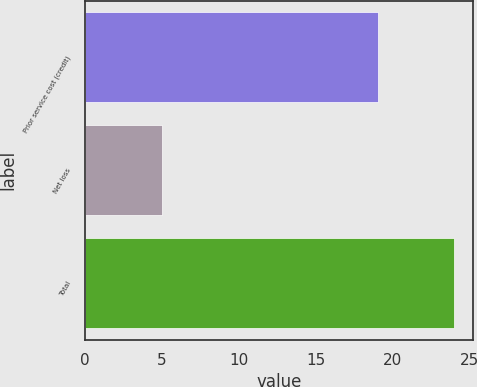Convert chart to OTSL. <chart><loc_0><loc_0><loc_500><loc_500><bar_chart><fcel>Prior service cost (credit)<fcel>Net loss<fcel>Total<nl><fcel>19<fcel>5<fcel>24<nl></chart> 